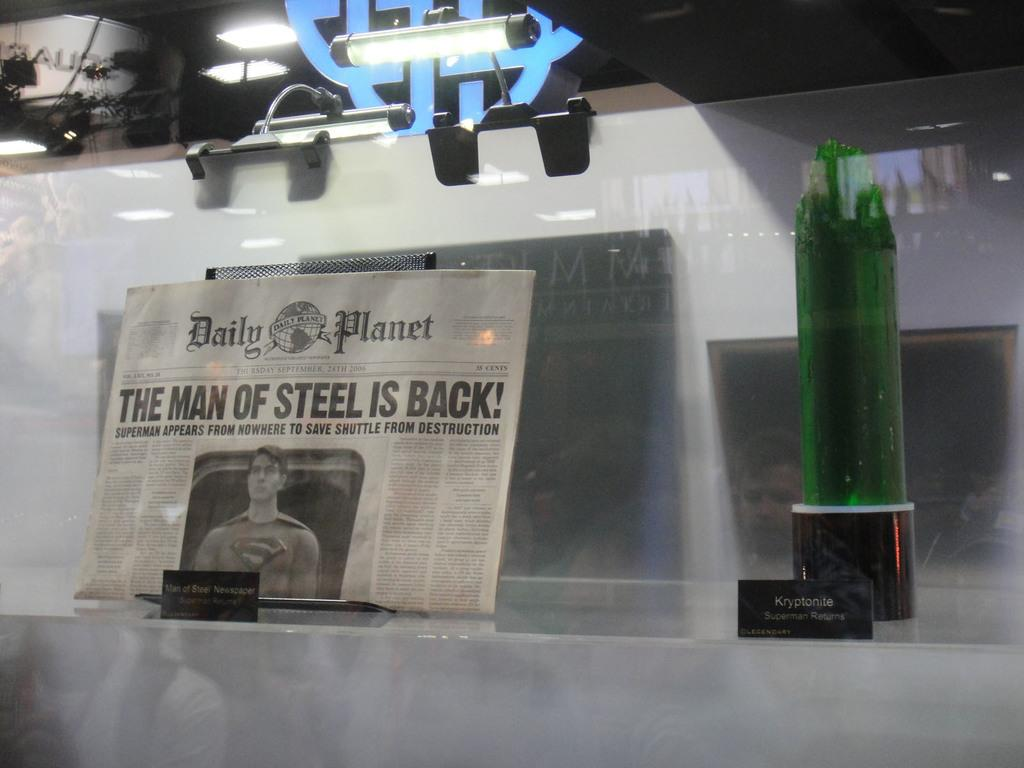<image>
Create a compact narrative representing the image presented. An issue of the Daily planet with the headline "The Man of Steel is Back!". 